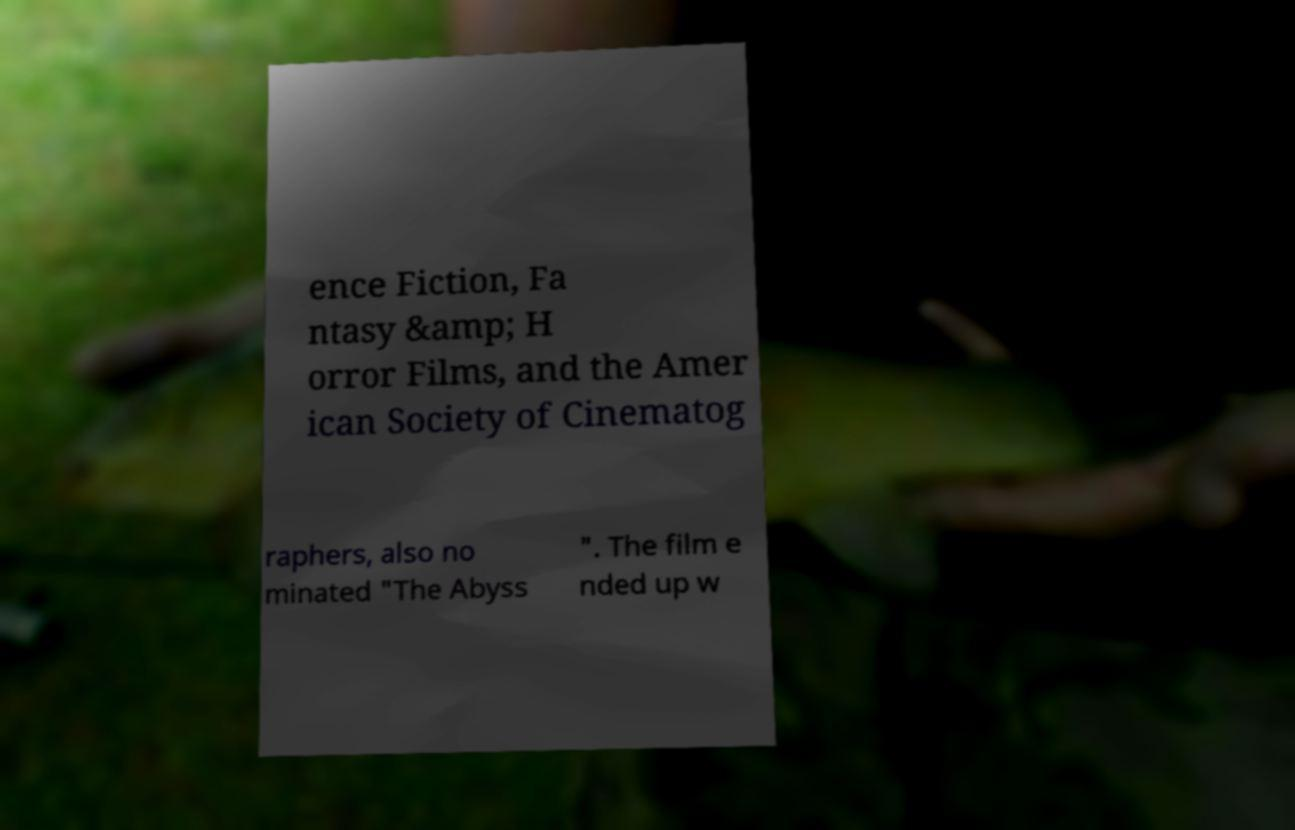Please identify and transcribe the text found in this image. ence Fiction, Fa ntasy &amp; H orror Films, and the Amer ican Society of Cinematog raphers, also no minated "The Abyss ". The film e nded up w 